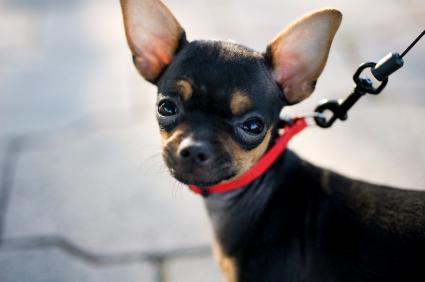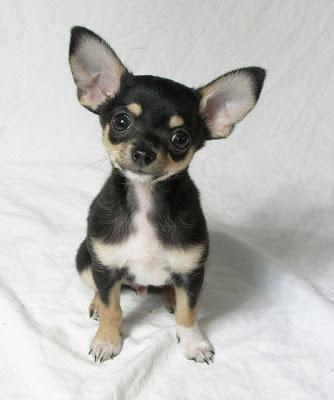The first image is the image on the left, the second image is the image on the right. Analyze the images presented: Is the assertion "One image shows a dog on a leash and the other shows a dog by white fabric." valid? Answer yes or no. Yes. 